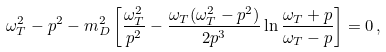<formula> <loc_0><loc_0><loc_500><loc_500>\omega _ { T } ^ { 2 } - p ^ { 2 } - m _ { D } ^ { 2 } \left [ \frac { \omega _ { T } ^ { 2 } } { p ^ { 2 } } - \frac { \omega _ { T } ( \omega _ { T } ^ { 2 } - p ^ { 2 } ) } { 2 p ^ { 3 } } \ln \frac { \omega _ { T } + p } { \omega _ { T } - p } \right ] = 0 \, ,</formula> 